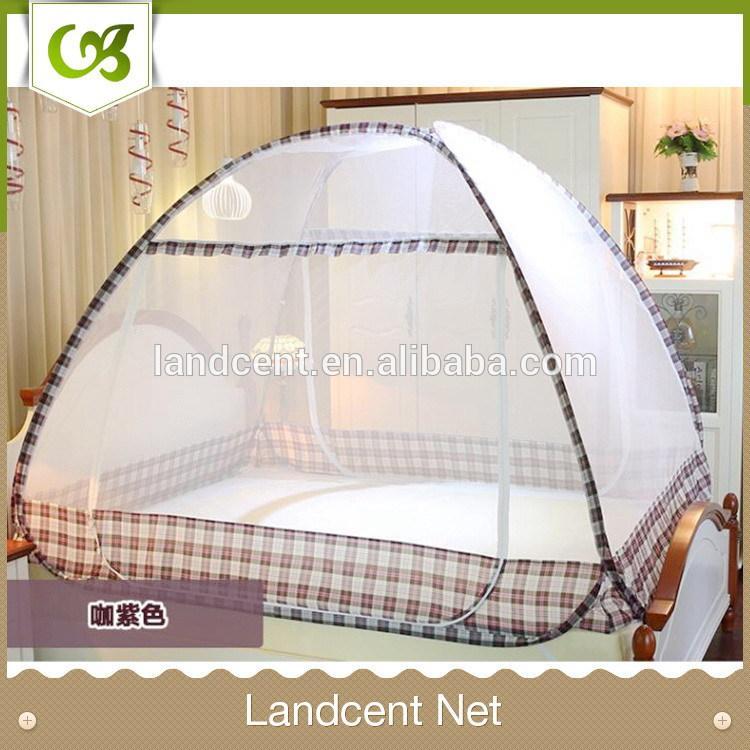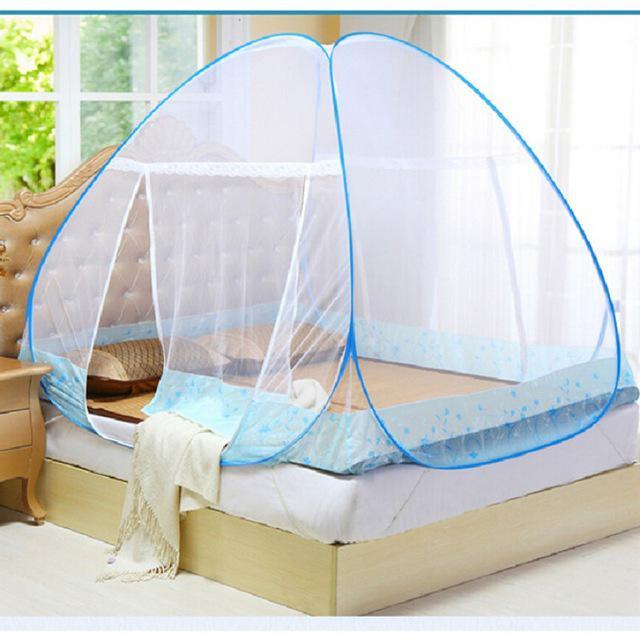The first image is the image on the left, the second image is the image on the right. Considering the images on both sides, is "A bed canopy has a checkered fabric strip around the bottom." valid? Answer yes or no. Yes. The first image is the image on the left, the second image is the image on the right. Examine the images to the left and right. Is the description "There is artwork on the wall behind the bed in the right image." accurate? Answer yes or no. No. 